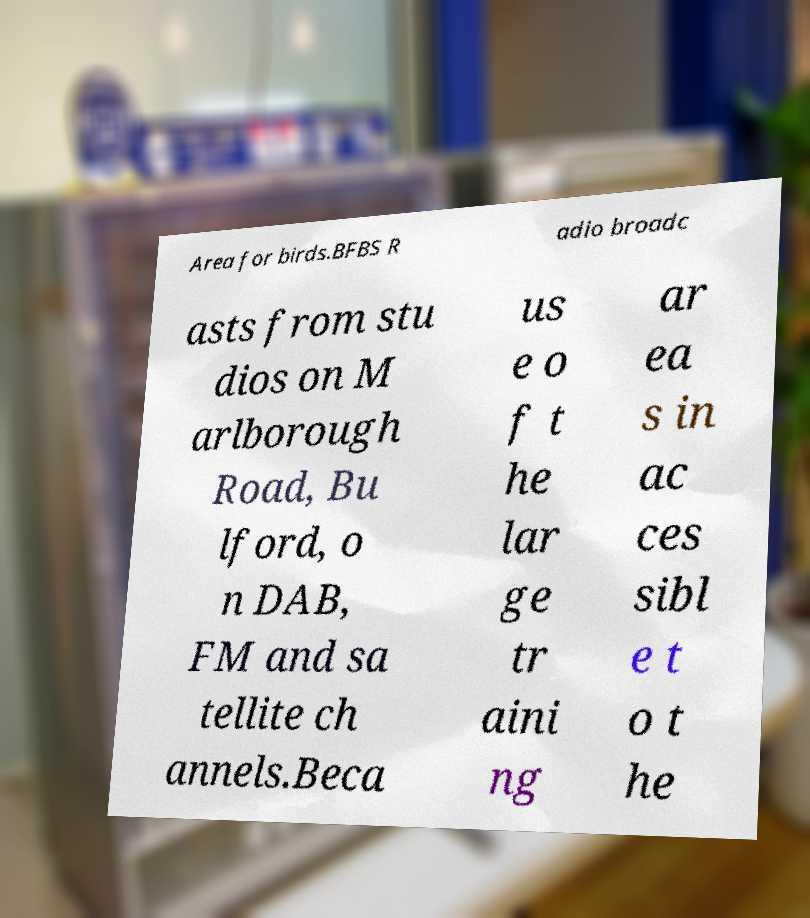There's text embedded in this image that I need extracted. Can you transcribe it verbatim? Area for birds.BFBS R adio broadc asts from stu dios on M arlborough Road, Bu lford, o n DAB, FM and sa tellite ch annels.Beca us e o f t he lar ge tr aini ng ar ea s in ac ces sibl e t o t he 